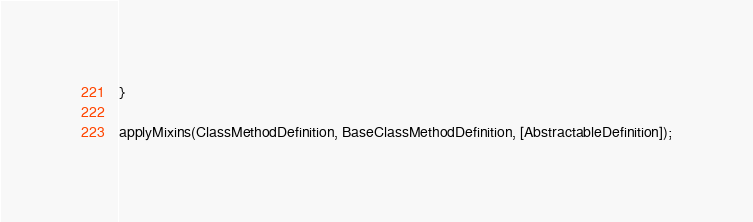<code> <loc_0><loc_0><loc_500><loc_500><_TypeScript_>}

applyMixins(ClassMethodDefinition, BaseClassMethodDefinition, [AbstractableDefinition]);
</code> 